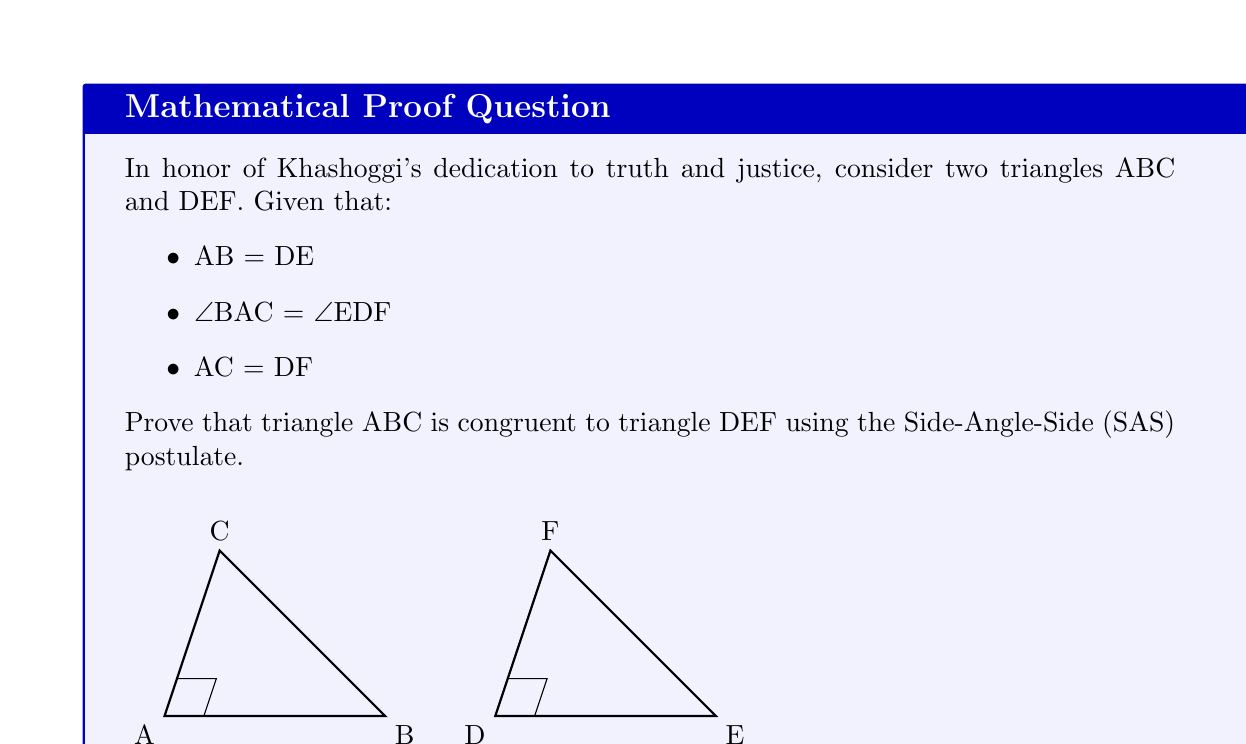Provide a solution to this math problem. To prove that triangle ABC is congruent to triangle DEF using the Side-Angle-Side (SAS) postulate, we need to show that two sides and the included angle of one triangle are congruent to the corresponding parts of the other triangle. Let's proceed step by step:

1) Given information:
   - AB = DE (first side)
   - ∠BAC = ∠EDF (included angle)
   - AC = DF (second side)

2) The SAS postulate states that if two sides and the included angle of one triangle are congruent to two sides and the included angle of another triangle, then the triangles are congruent.

3) In this case:
   - AB corresponds to DE (given)
   - ∠BAC corresponds to ∠EDF (given)
   - AC corresponds to DF (given)

4) We can see that:
   - One side of triangle ABC (AB) is congruent to the corresponding side of triangle DEF (DE)
   - The angle included between these sides in triangle ABC (∠BAC) is congruent to the corresponding angle in triangle DEF (∠EDF)
   - The other side adjacent to this angle in triangle ABC (AC) is congruent to the corresponding side in triangle DEF (DF)

5) This exactly satisfies the conditions for the SAS postulate.

Therefore, by the Side-Angle-Side (SAS) postulate, we can conclude that triangle ABC is congruent to triangle DEF.
Answer: $\triangle ABC \cong \triangle DEF$ by SAS 